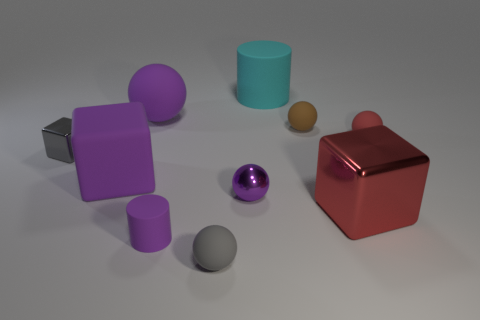Do the big block left of the large cyan cylinder and the sphere that is to the left of the tiny matte cylinder have the same material?
Offer a terse response. Yes. There is a rubber cylinder behind the rubber thing that is right of the red cube; how big is it?
Offer a very short reply. Large. What material is the other big thing that is the same shape as the brown matte object?
Give a very brief answer. Rubber. There is a small thing that is left of the tiny purple rubber thing; is it the same shape as the small purple thing behind the large metallic block?
Provide a succinct answer. No. Are there more tiny purple things than small balls?
Ensure brevity in your answer.  No. What size is the purple rubber cylinder?
Your answer should be very brief. Small. How many other things are the same color as the big shiny thing?
Ensure brevity in your answer.  1. Is the material of the cyan cylinder that is behind the tiny gray metal thing the same as the gray ball?
Offer a very short reply. Yes. Are there fewer cylinders to the left of the brown thing than rubber things behind the tiny purple shiny ball?
Offer a very short reply. Yes. How many other objects are the same material as the tiny purple cylinder?
Offer a very short reply. 6. 